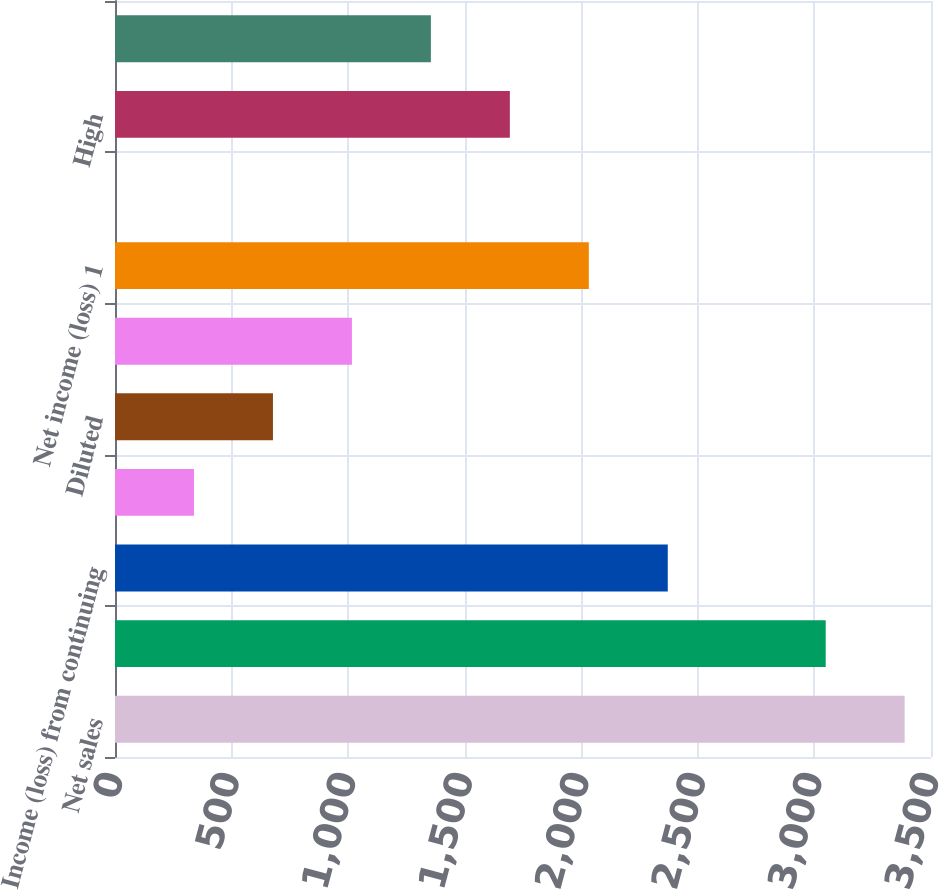Convert chart to OTSL. <chart><loc_0><loc_0><loc_500><loc_500><bar_chart><fcel>Net sales<fcel>Gross margin 1<fcel>Income (loss) from continuing<fcel>Basic<fcel>Diluted<fcel>(Loss) income from<fcel>Net income (loss) 1<fcel>Cash dividends declared per<fcel>High<fcel>Low<nl><fcel>3387.03<fcel>3048.34<fcel>2370.96<fcel>338.82<fcel>677.51<fcel>1016.2<fcel>2032.27<fcel>0.13<fcel>1693.58<fcel>1354.89<nl></chart> 